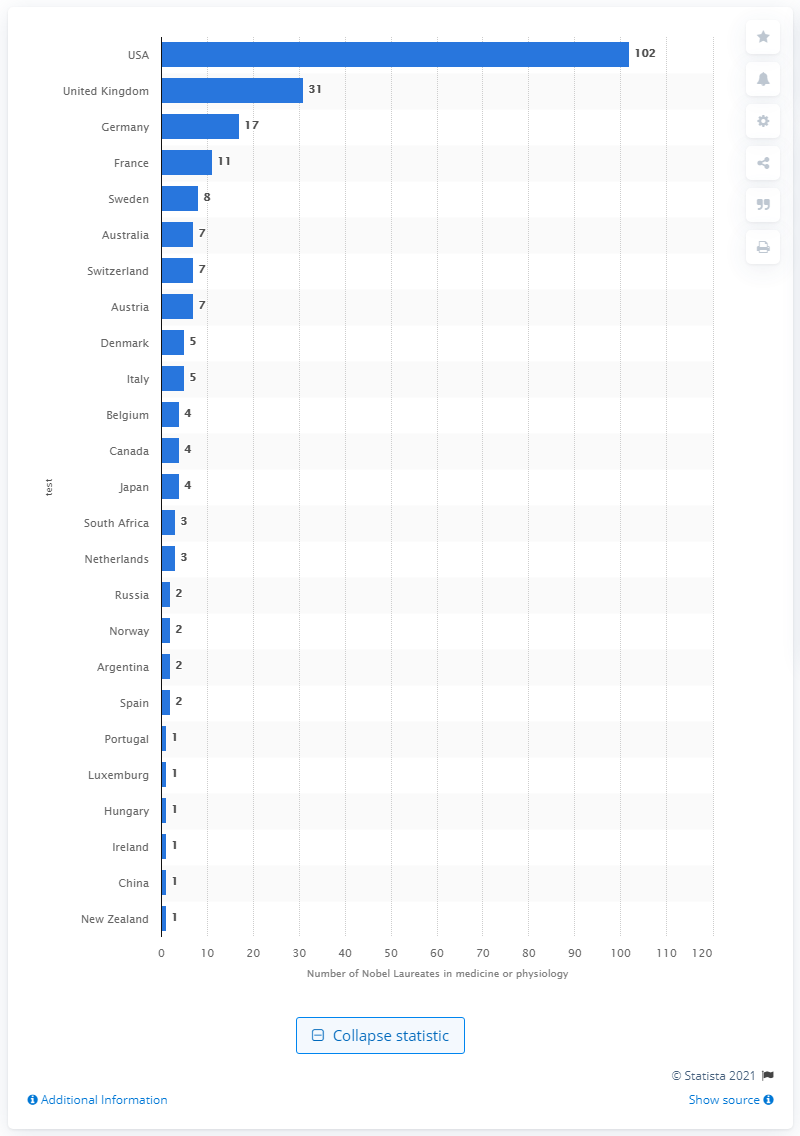Highlight a few significant elements in this photo. Since 1901, 102 individuals from the United States have been awarded the Nobel Prize. As of 2020, there were 31 Nobel Prize Laureates from the United Kingdom. 